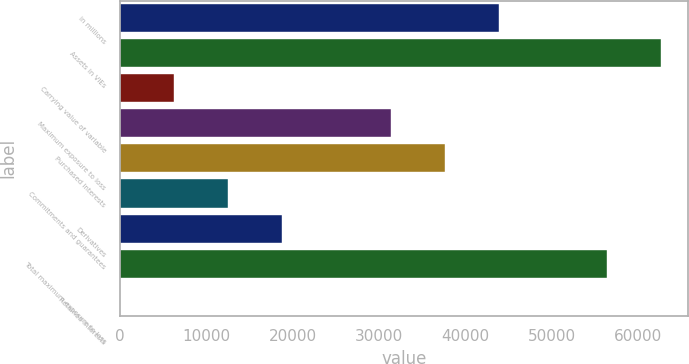<chart> <loc_0><loc_0><loc_500><loc_500><bar_chart><fcel>in millions<fcel>Assets in VIEs<fcel>Carrying value of variable<fcel>Maximum exposure to loss<fcel>Purchased interests<fcel>Commitments and guarantees<fcel>Derivatives<fcel>Total maximum exposure to loss<fcel>Retained interests<nl><fcel>43871.3<fcel>62672<fcel>6269.9<fcel>31337.5<fcel>37604.4<fcel>12536.8<fcel>18803.7<fcel>56405.1<fcel>3<nl></chart> 